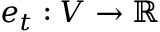Convert formula to latex. <formula><loc_0><loc_0><loc_500><loc_500>e _ { t } \colon V \to \mathbb { R }</formula> 